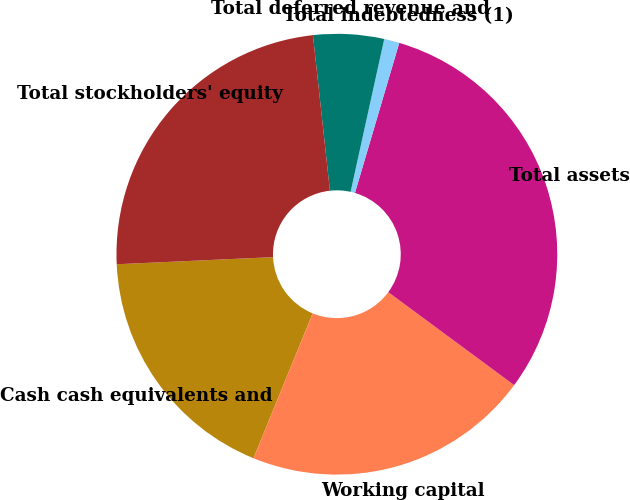Convert chart to OTSL. <chart><loc_0><loc_0><loc_500><loc_500><pie_chart><fcel>Cash cash equivalents and<fcel>Working capital<fcel>Total assets<fcel>Total indebtedness (1)<fcel>Total deferred revenue and<fcel>Total stockholders' equity<nl><fcel>18.1%<fcel>21.05%<fcel>30.55%<fcel>1.12%<fcel>5.18%<fcel>23.99%<nl></chart> 